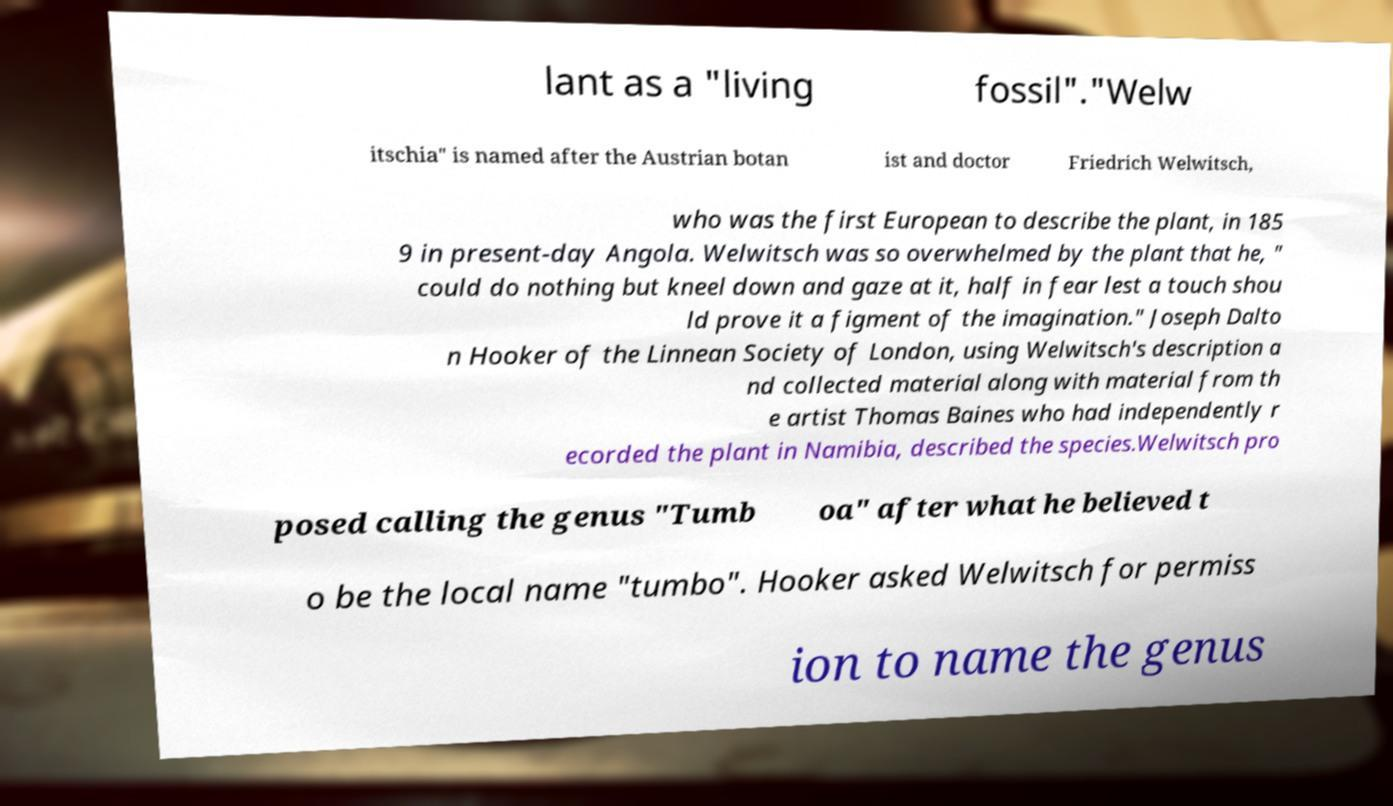Can you accurately transcribe the text from the provided image for me? lant as a "living fossil"."Welw itschia" is named after the Austrian botan ist and doctor Friedrich Welwitsch, who was the first European to describe the plant, in 185 9 in present-day Angola. Welwitsch was so overwhelmed by the plant that he, " could do nothing but kneel down and gaze at it, half in fear lest a touch shou ld prove it a figment of the imagination." Joseph Dalto n Hooker of the Linnean Society of London, using Welwitsch's description a nd collected material along with material from th e artist Thomas Baines who had independently r ecorded the plant in Namibia, described the species.Welwitsch pro posed calling the genus "Tumb oa" after what he believed t o be the local name "tumbo". Hooker asked Welwitsch for permiss ion to name the genus 